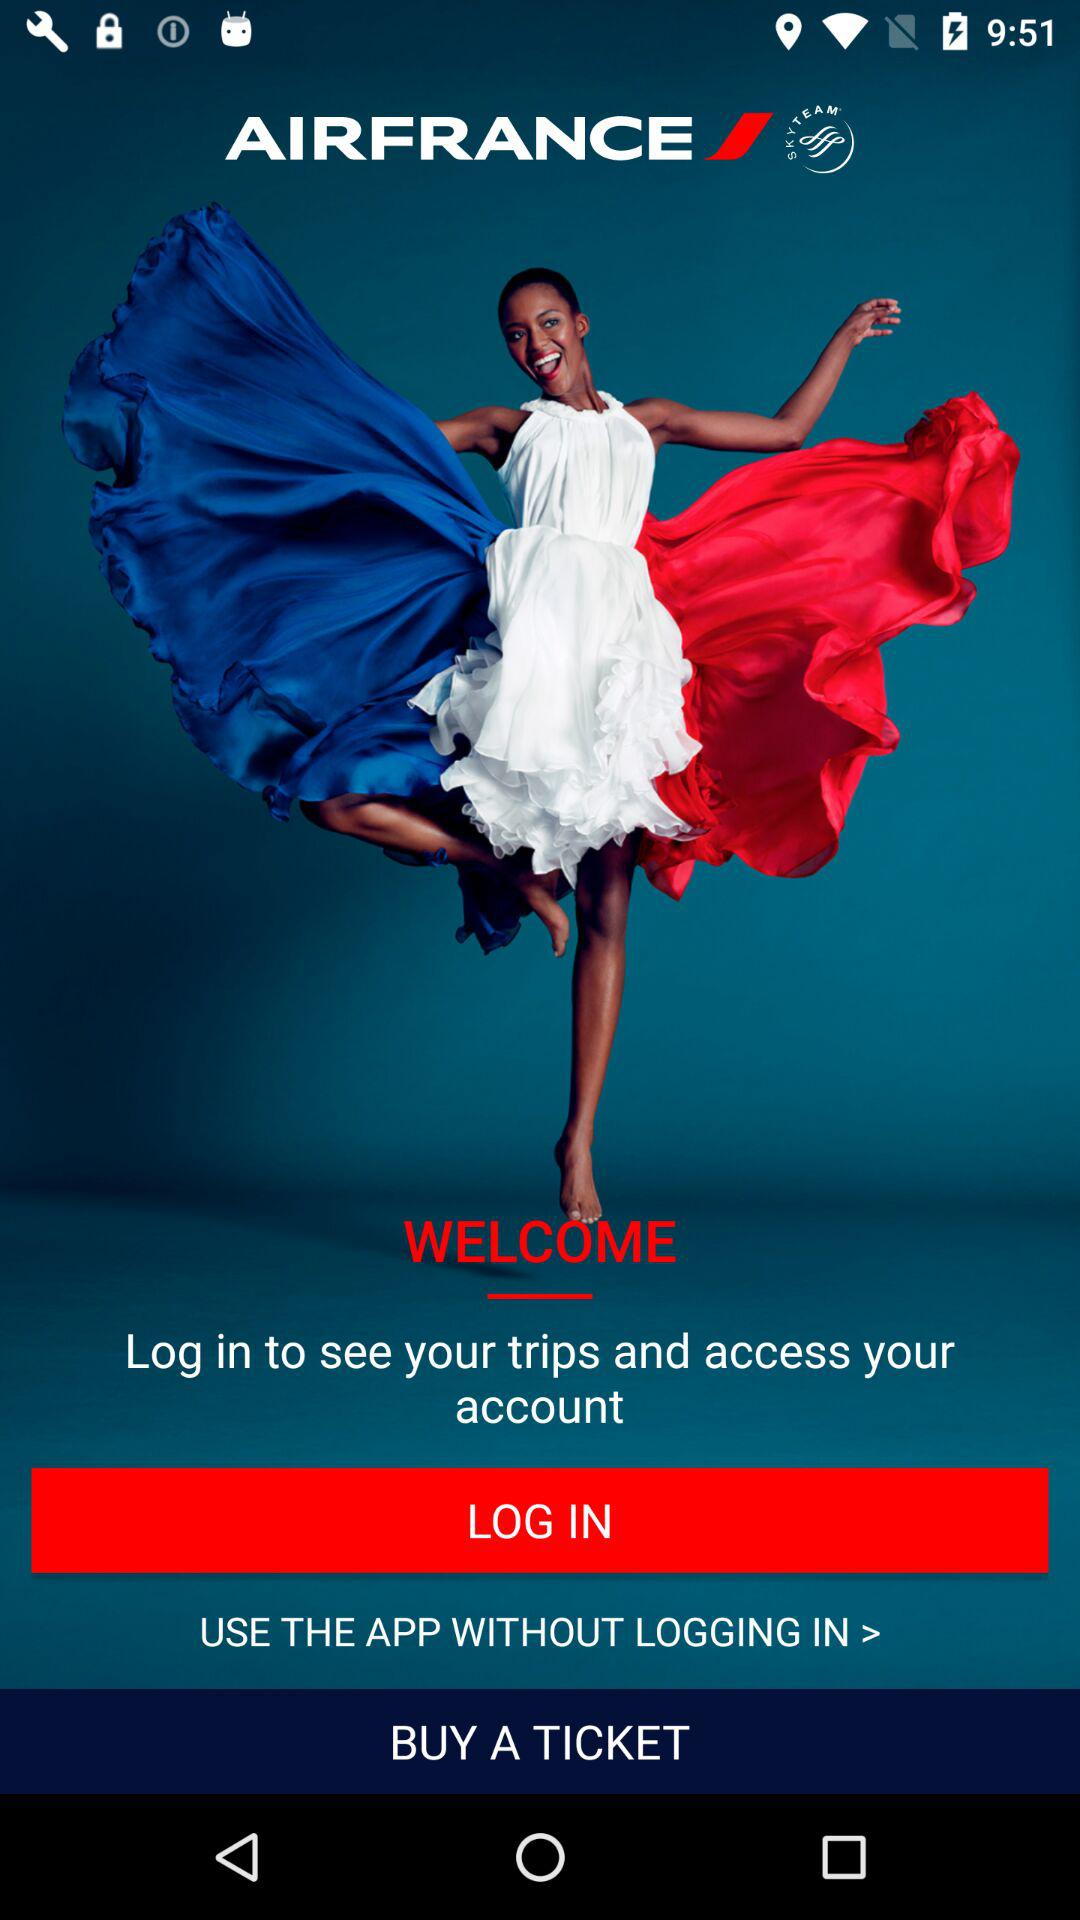What is the application name? The application name is "AIRFRANCE". 